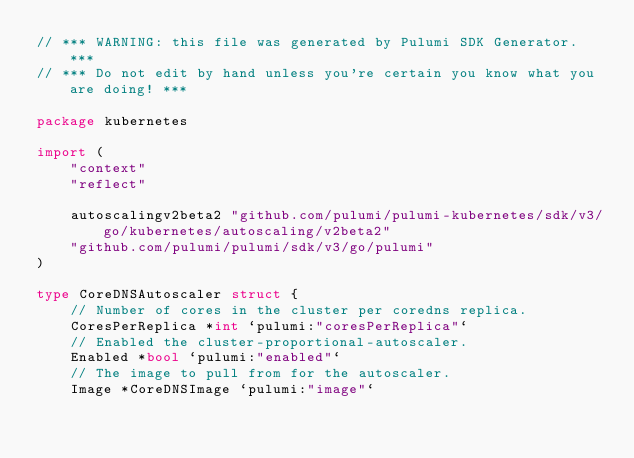Convert code to text. <code><loc_0><loc_0><loc_500><loc_500><_Go_>// *** WARNING: this file was generated by Pulumi SDK Generator. ***
// *** Do not edit by hand unless you're certain you know what you are doing! ***

package kubernetes

import (
	"context"
	"reflect"

	autoscalingv2beta2 "github.com/pulumi/pulumi-kubernetes/sdk/v3/go/kubernetes/autoscaling/v2beta2"
	"github.com/pulumi/pulumi/sdk/v3/go/pulumi"
)

type CoreDNSAutoscaler struct {
	// Number of cores in the cluster per coredns replica.
	CoresPerReplica *int `pulumi:"coresPerReplica"`
	// Enabled the cluster-proportional-autoscaler.
	Enabled *bool `pulumi:"enabled"`
	// The image to pull from for the autoscaler.
	Image *CoreDNSImage `pulumi:"image"`</code> 